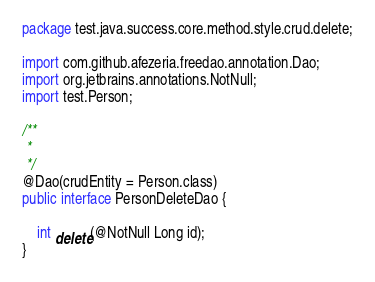Convert code to text. <code><loc_0><loc_0><loc_500><loc_500><_Java_>package test.java.success.core.method.style.crud.delete;

import com.github.afezeria.freedao.annotation.Dao;
import org.jetbrains.annotations.NotNull;
import test.Person;

/**
 *
 */
@Dao(crudEntity = Person.class)
public interface PersonDeleteDao {

    int delete(@NotNull Long id);
}
</code> 